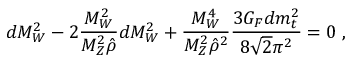Convert formula to latex. <formula><loc_0><loc_0><loc_500><loc_500>d M _ { W } ^ { 2 } - 2 \frac { M _ { W } ^ { 2 } } { M _ { Z } ^ { 2 } \hat { \rho } } d M _ { W } ^ { 2 } + \frac { M _ { W } ^ { 4 } } { M _ { Z } ^ { 2 } \hat { \rho } ^ { 2 } } \frac { 3 G _ { F } d m _ { t } ^ { 2 } } { 8 \sqrt { 2 } \pi ^ { 2 } } = 0 \, ,</formula> 